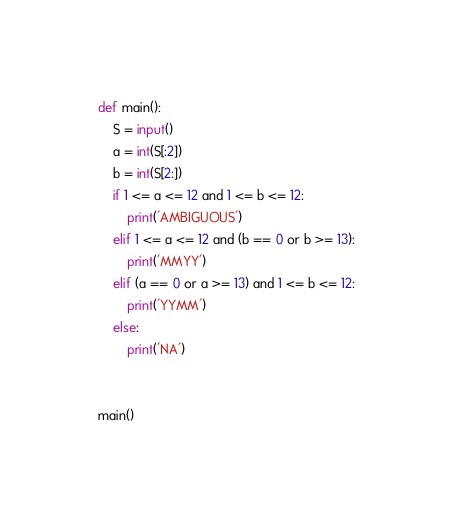Convert code to text. <code><loc_0><loc_0><loc_500><loc_500><_Python_>def main():
    S = input()
    a = int(S[:2])
    b = int(S[2:])
    if 1 <= a <= 12 and 1 <= b <= 12:
        print('AMBIGUOUS')
    elif 1 <= a <= 12 and (b == 0 or b >= 13):
        print('MMYY')
    elif (a == 0 or a >= 13) and 1 <= b <= 12:
        print('YYMM')
    else:
        print('NA')


main()
</code> 